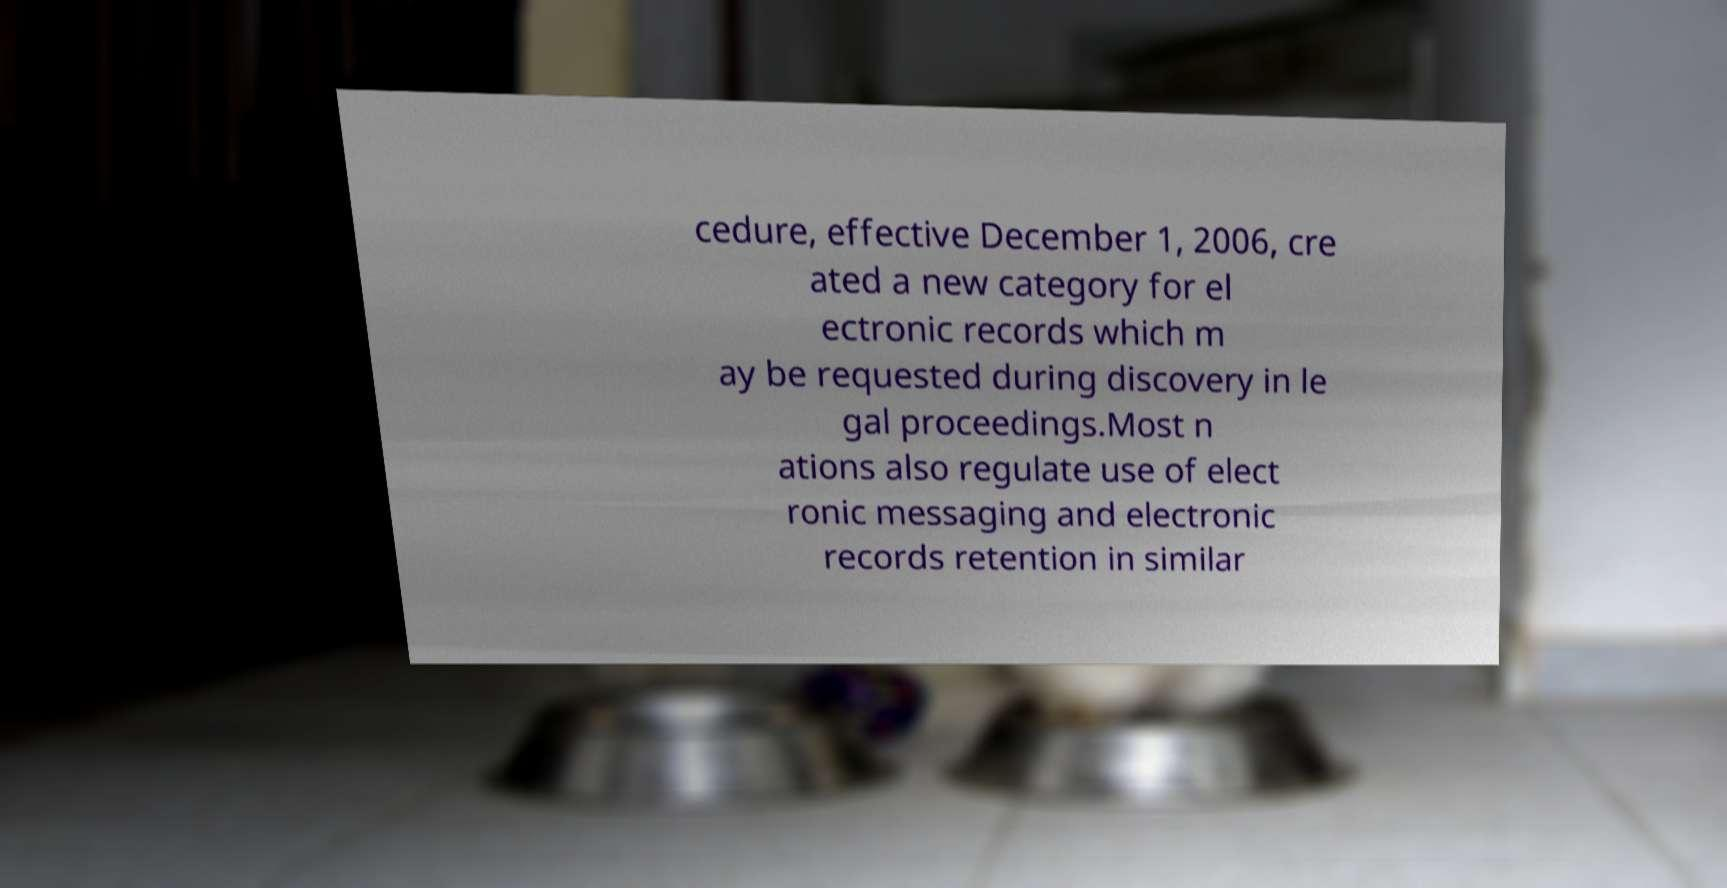Can you accurately transcribe the text from the provided image for me? cedure, effective December 1, 2006, cre ated a new category for el ectronic records which m ay be requested during discovery in le gal proceedings.Most n ations also regulate use of elect ronic messaging and electronic records retention in similar 